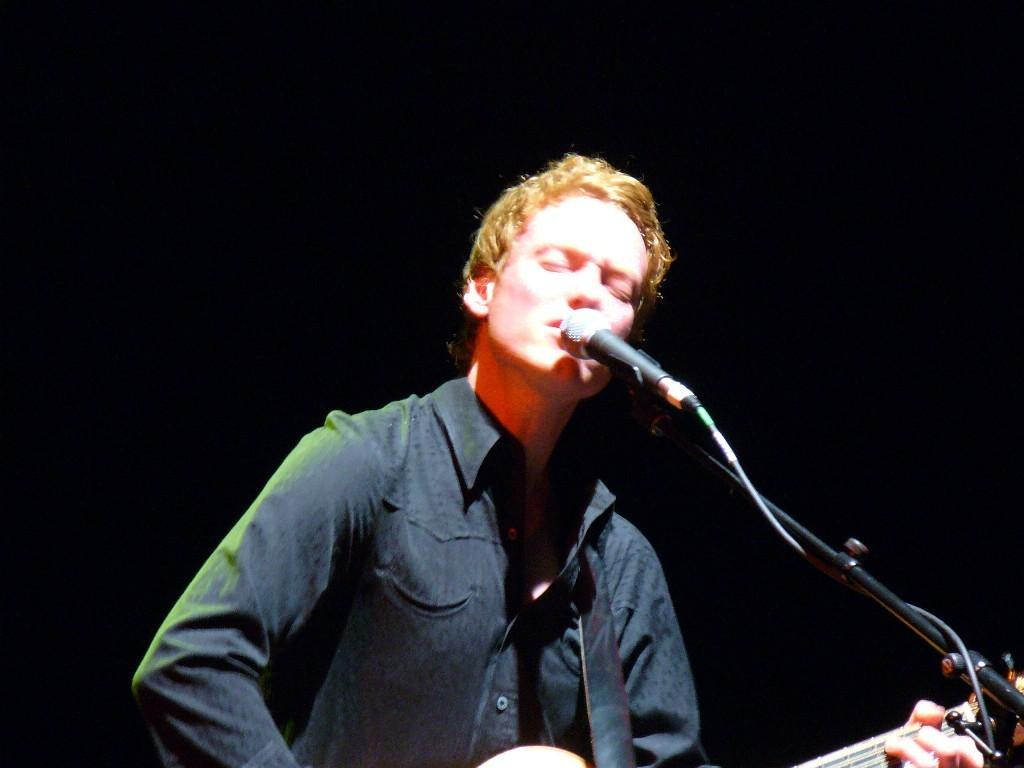What is the main subject of the image? There is a person in the image. What is the person doing in the image? The person is standing and singing into a microphone. What object is the person holding in his hand? The person is holding a guitar in his hand. What type of straw is the person using to play the guitar in the image? There is no straw present in the image; the person is holding a guitar. What part of the sun can be seen in the image? The image does not show any part of the sun; it features a person holding a guitar and singing into a microphone. 